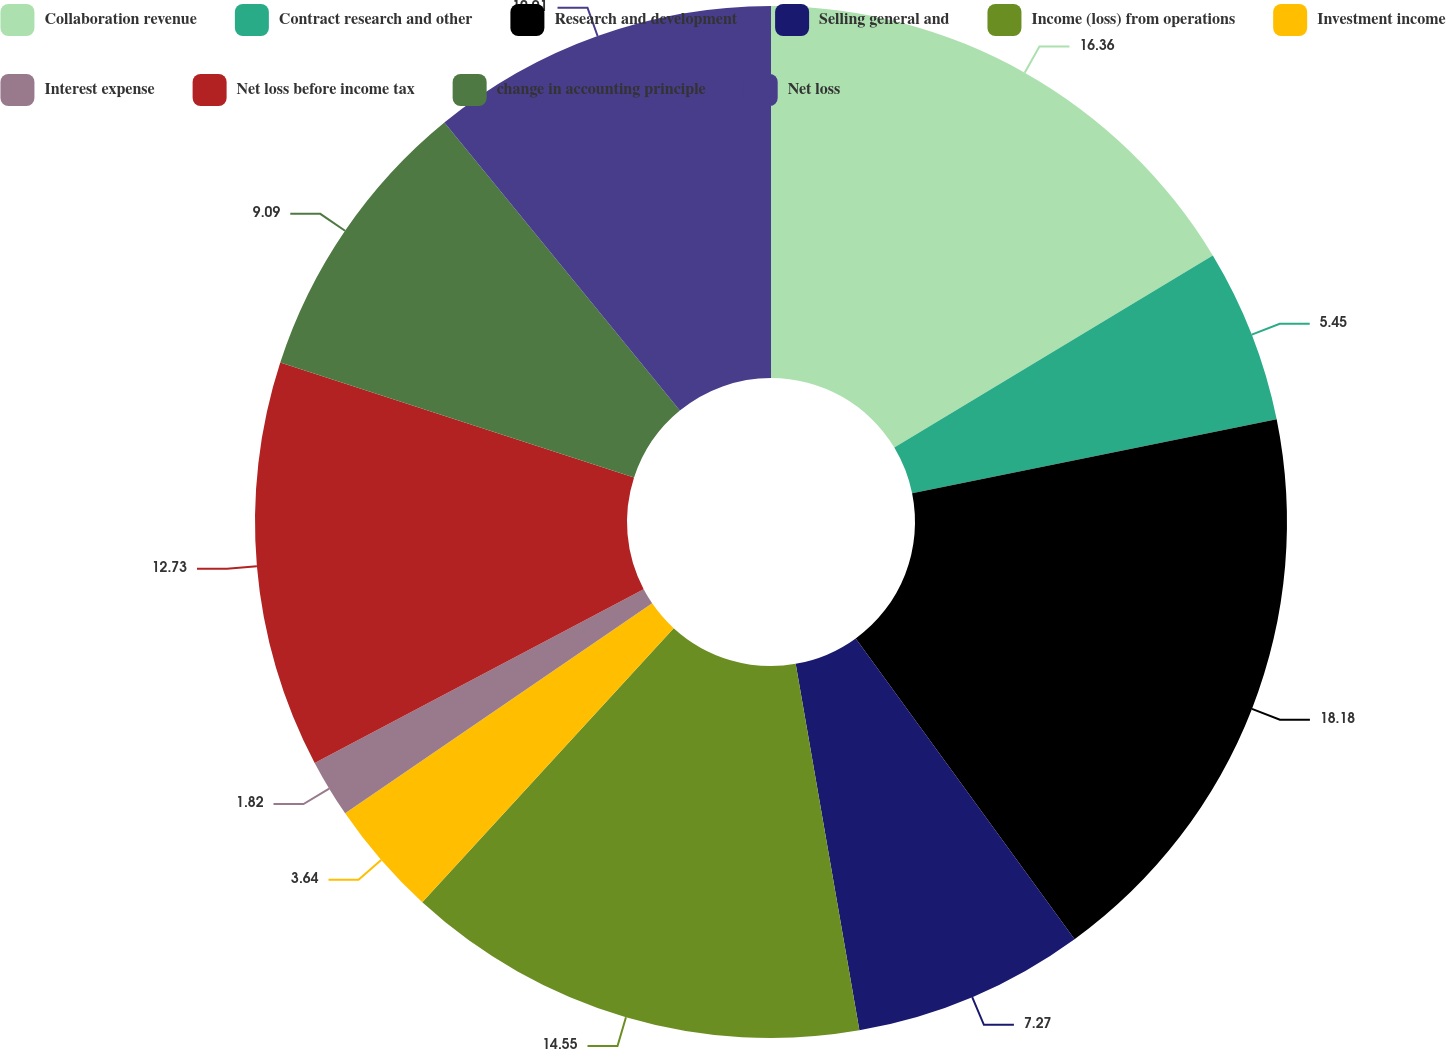Convert chart. <chart><loc_0><loc_0><loc_500><loc_500><pie_chart><fcel>Collaboration revenue<fcel>Contract research and other<fcel>Research and development<fcel>Selling general and<fcel>Income (loss) from operations<fcel>Investment income<fcel>Interest expense<fcel>Net loss before income tax<fcel>change in accounting principle<fcel>Net loss<nl><fcel>16.36%<fcel>5.45%<fcel>18.18%<fcel>7.27%<fcel>14.55%<fcel>3.64%<fcel>1.82%<fcel>12.73%<fcel>9.09%<fcel>10.91%<nl></chart> 